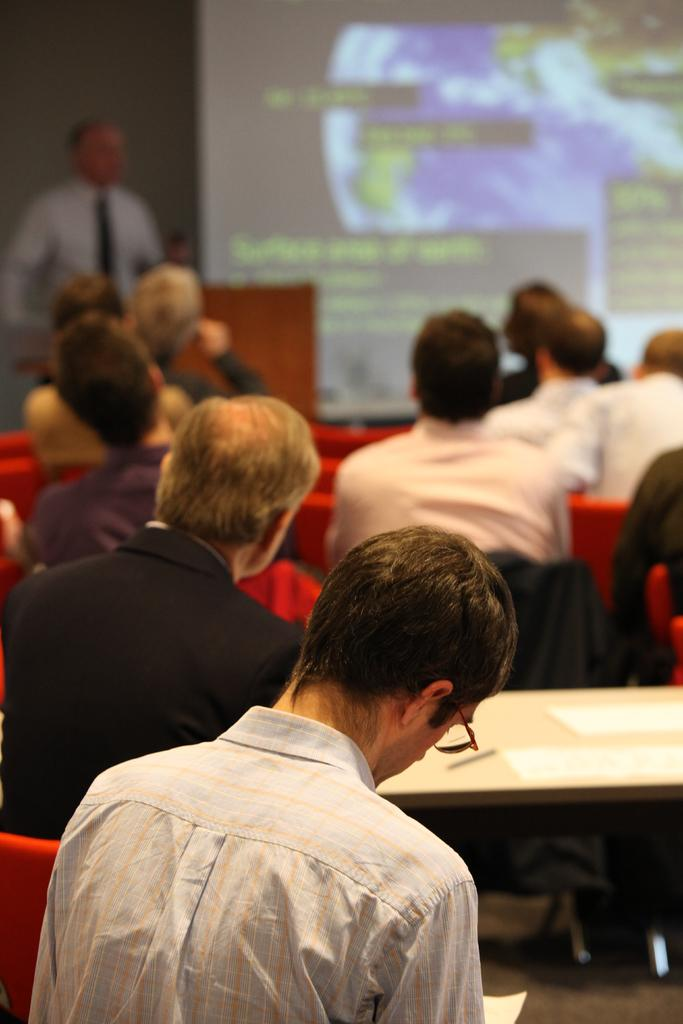What are the people in the image doing? The people in the image are sitting on chairs. What else can be seen in the image besides the people sitting on chairs? There are tables in the image. What is happening in the background of the image? There is a man standing near a podium, and there is a screen in the background. What type of pets are being treated on the tables in the image? There are no pets present in the image, and the tables are not being used for any treatment. 